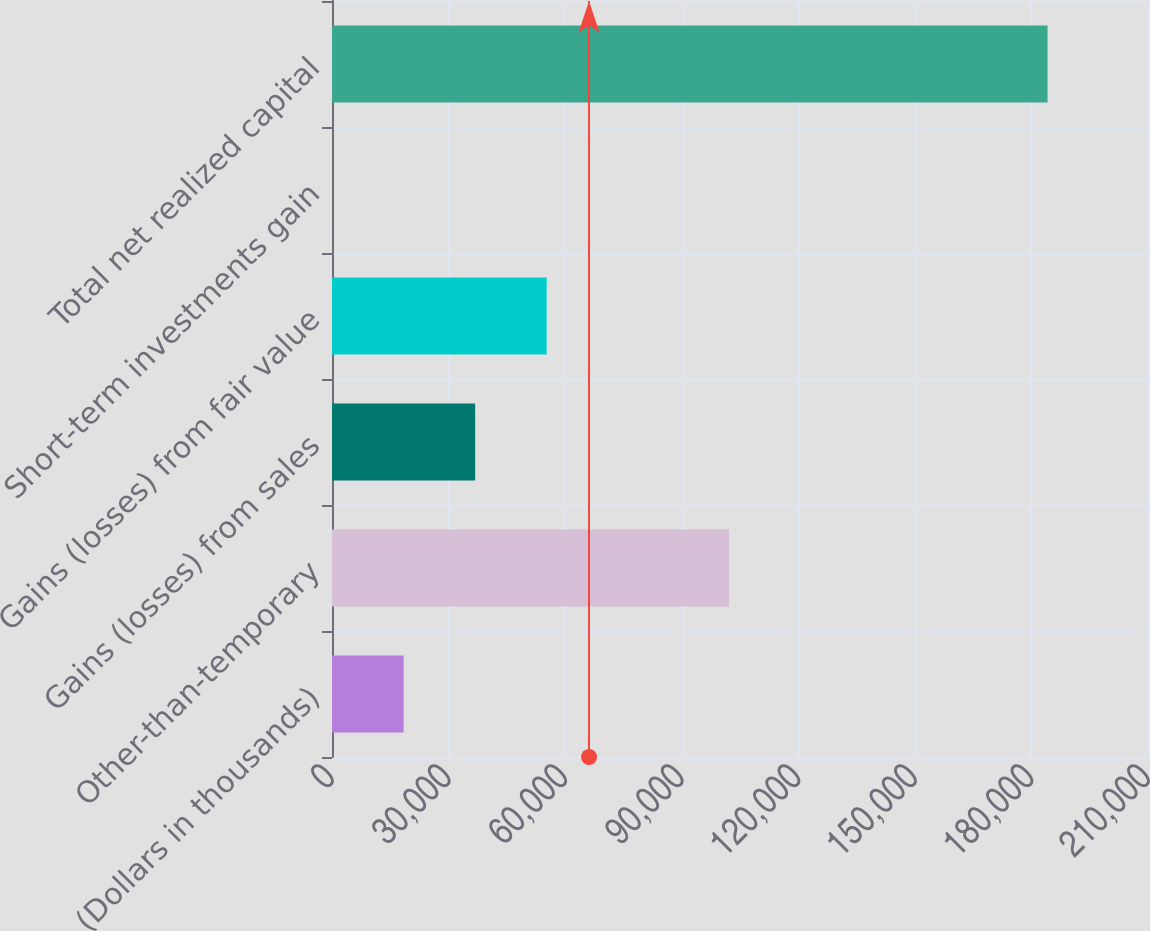Convert chart to OTSL. <chart><loc_0><loc_0><loc_500><loc_500><bar_chart><fcel>(Dollars in thousands)<fcel>Other-than-temporary<fcel>Gains (losses) from sales<fcel>Gains (losses) from fair value<fcel>Short-term investments gain<fcel>Total net realized capital<nl><fcel>18429.1<fcel>102199<fcel>36842.2<fcel>55255.3<fcel>16<fcel>184147<nl></chart> 